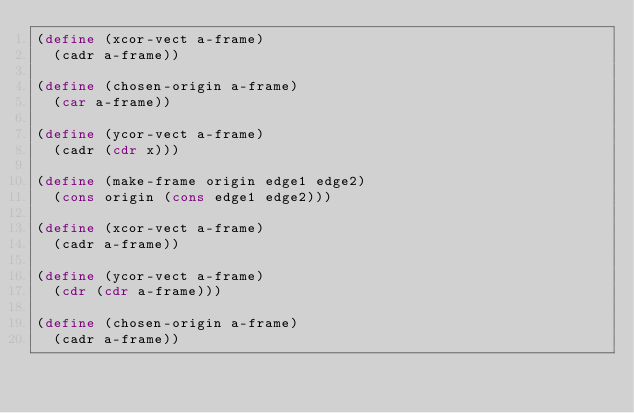<code> <loc_0><loc_0><loc_500><loc_500><_Scheme_>(define (xcor-vect a-frame)
  (cadr a-frame))

(define (chosen-origin a-frame)
  (car a-frame))

(define (ycor-vect a-frame)
  (cadr (cdr x)))

(define (make-frame origin edge1 edge2)
  (cons origin (cons edge1 edge2)))

(define (xcor-vect a-frame)
  (cadr a-frame))

(define (ycor-vect a-frame)
  (cdr (cdr a-frame)))

(define (chosen-origin a-frame)
  (cadr a-frame))
</code> 